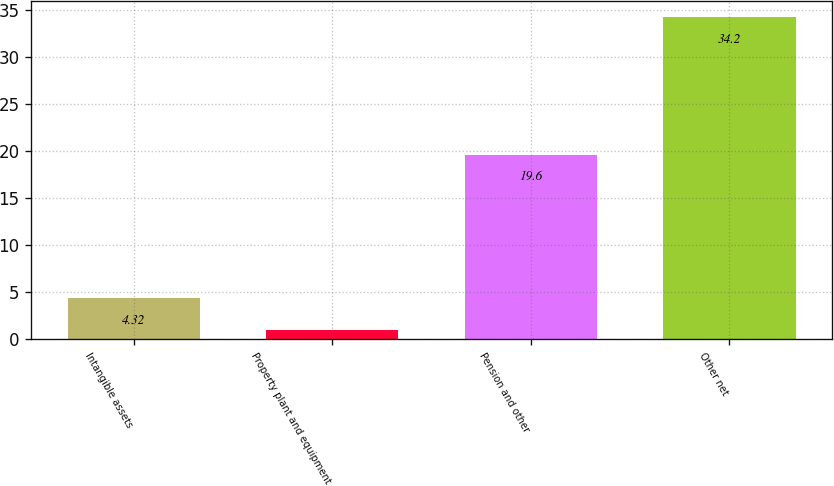Convert chart to OTSL. <chart><loc_0><loc_0><loc_500><loc_500><bar_chart><fcel>Intangible assets<fcel>Property plant and equipment<fcel>Pension and other<fcel>Other net<nl><fcel>4.32<fcel>1<fcel>19.6<fcel>34.2<nl></chart> 